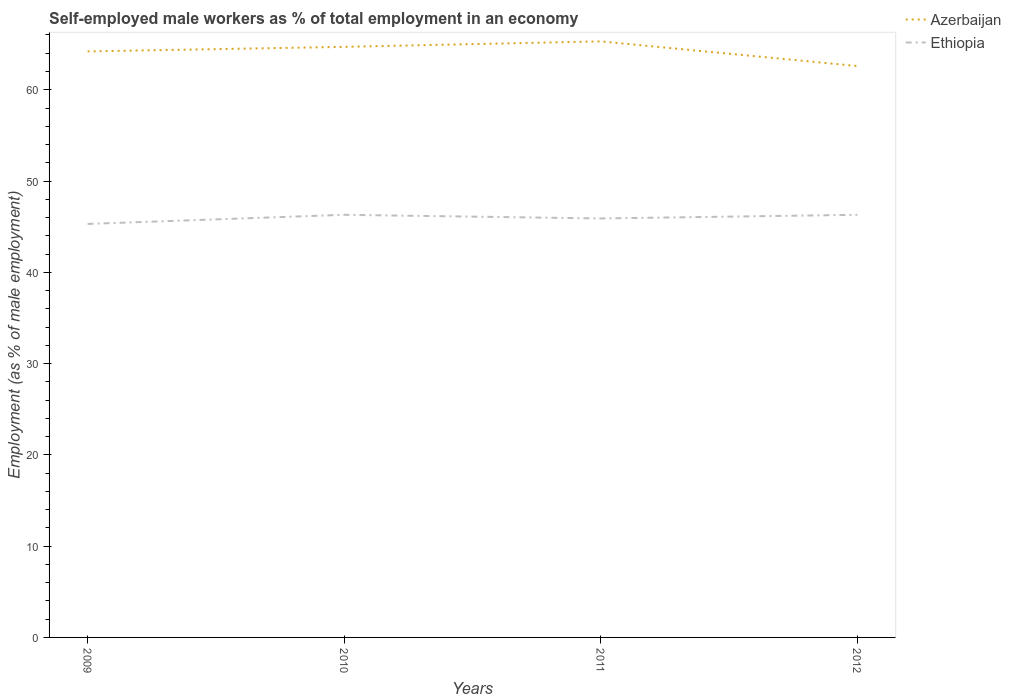Is the number of lines equal to the number of legend labels?
Give a very brief answer. Yes. Across all years, what is the maximum percentage of self-employed male workers in Ethiopia?
Make the answer very short. 45.3. In which year was the percentage of self-employed male workers in Ethiopia maximum?
Provide a succinct answer. 2009. What is the difference between the highest and the second highest percentage of self-employed male workers in Azerbaijan?
Offer a very short reply. 2.7. Is the percentage of self-employed male workers in Ethiopia strictly greater than the percentage of self-employed male workers in Azerbaijan over the years?
Make the answer very short. Yes. How many lines are there?
Provide a succinct answer. 2. How many years are there in the graph?
Make the answer very short. 4. Where does the legend appear in the graph?
Offer a very short reply. Top right. How many legend labels are there?
Your answer should be very brief. 2. What is the title of the graph?
Your response must be concise. Self-employed male workers as % of total employment in an economy. What is the label or title of the X-axis?
Ensure brevity in your answer.  Years. What is the label or title of the Y-axis?
Offer a very short reply. Employment (as % of male employment). What is the Employment (as % of male employment) in Azerbaijan in 2009?
Ensure brevity in your answer.  64.2. What is the Employment (as % of male employment) of Ethiopia in 2009?
Ensure brevity in your answer.  45.3. What is the Employment (as % of male employment) in Azerbaijan in 2010?
Keep it short and to the point. 64.7. What is the Employment (as % of male employment) of Ethiopia in 2010?
Give a very brief answer. 46.3. What is the Employment (as % of male employment) in Azerbaijan in 2011?
Give a very brief answer. 65.3. What is the Employment (as % of male employment) in Ethiopia in 2011?
Offer a terse response. 45.9. What is the Employment (as % of male employment) of Azerbaijan in 2012?
Give a very brief answer. 62.6. What is the Employment (as % of male employment) of Ethiopia in 2012?
Offer a terse response. 46.3. Across all years, what is the maximum Employment (as % of male employment) of Azerbaijan?
Provide a short and direct response. 65.3. Across all years, what is the maximum Employment (as % of male employment) in Ethiopia?
Provide a succinct answer. 46.3. Across all years, what is the minimum Employment (as % of male employment) in Azerbaijan?
Provide a short and direct response. 62.6. Across all years, what is the minimum Employment (as % of male employment) of Ethiopia?
Give a very brief answer. 45.3. What is the total Employment (as % of male employment) in Azerbaijan in the graph?
Give a very brief answer. 256.8. What is the total Employment (as % of male employment) in Ethiopia in the graph?
Your answer should be very brief. 183.8. What is the difference between the Employment (as % of male employment) in Azerbaijan in 2009 and that in 2012?
Ensure brevity in your answer.  1.6. What is the difference between the Employment (as % of male employment) of Ethiopia in 2009 and that in 2012?
Offer a very short reply. -1. What is the difference between the Employment (as % of male employment) in Ethiopia in 2011 and that in 2012?
Keep it short and to the point. -0.4. What is the difference between the Employment (as % of male employment) in Azerbaijan in 2009 and the Employment (as % of male employment) in Ethiopia in 2012?
Your response must be concise. 17.9. What is the difference between the Employment (as % of male employment) of Azerbaijan in 2010 and the Employment (as % of male employment) of Ethiopia in 2012?
Provide a short and direct response. 18.4. What is the difference between the Employment (as % of male employment) in Azerbaijan in 2011 and the Employment (as % of male employment) in Ethiopia in 2012?
Keep it short and to the point. 19. What is the average Employment (as % of male employment) in Azerbaijan per year?
Provide a short and direct response. 64.2. What is the average Employment (as % of male employment) in Ethiopia per year?
Your response must be concise. 45.95. In the year 2009, what is the difference between the Employment (as % of male employment) in Azerbaijan and Employment (as % of male employment) in Ethiopia?
Your answer should be compact. 18.9. In the year 2010, what is the difference between the Employment (as % of male employment) in Azerbaijan and Employment (as % of male employment) in Ethiopia?
Offer a terse response. 18.4. In the year 2012, what is the difference between the Employment (as % of male employment) in Azerbaijan and Employment (as % of male employment) in Ethiopia?
Make the answer very short. 16.3. What is the ratio of the Employment (as % of male employment) of Ethiopia in 2009 to that in 2010?
Give a very brief answer. 0.98. What is the ratio of the Employment (as % of male employment) in Azerbaijan in 2009 to that in 2011?
Make the answer very short. 0.98. What is the ratio of the Employment (as % of male employment) of Ethiopia in 2009 to that in 2011?
Ensure brevity in your answer.  0.99. What is the ratio of the Employment (as % of male employment) in Azerbaijan in 2009 to that in 2012?
Your answer should be very brief. 1.03. What is the ratio of the Employment (as % of male employment) in Ethiopia in 2009 to that in 2012?
Your response must be concise. 0.98. What is the ratio of the Employment (as % of male employment) in Azerbaijan in 2010 to that in 2011?
Provide a short and direct response. 0.99. What is the ratio of the Employment (as % of male employment) in Ethiopia in 2010 to that in 2011?
Provide a succinct answer. 1.01. What is the ratio of the Employment (as % of male employment) of Azerbaijan in 2010 to that in 2012?
Make the answer very short. 1.03. What is the ratio of the Employment (as % of male employment) in Ethiopia in 2010 to that in 2012?
Ensure brevity in your answer.  1. What is the ratio of the Employment (as % of male employment) of Azerbaijan in 2011 to that in 2012?
Ensure brevity in your answer.  1.04. What is the ratio of the Employment (as % of male employment) in Ethiopia in 2011 to that in 2012?
Offer a very short reply. 0.99. What is the difference between the highest and the second highest Employment (as % of male employment) of Azerbaijan?
Offer a very short reply. 0.6. What is the difference between the highest and the second highest Employment (as % of male employment) in Ethiopia?
Offer a very short reply. 0. What is the difference between the highest and the lowest Employment (as % of male employment) of Azerbaijan?
Your response must be concise. 2.7. 